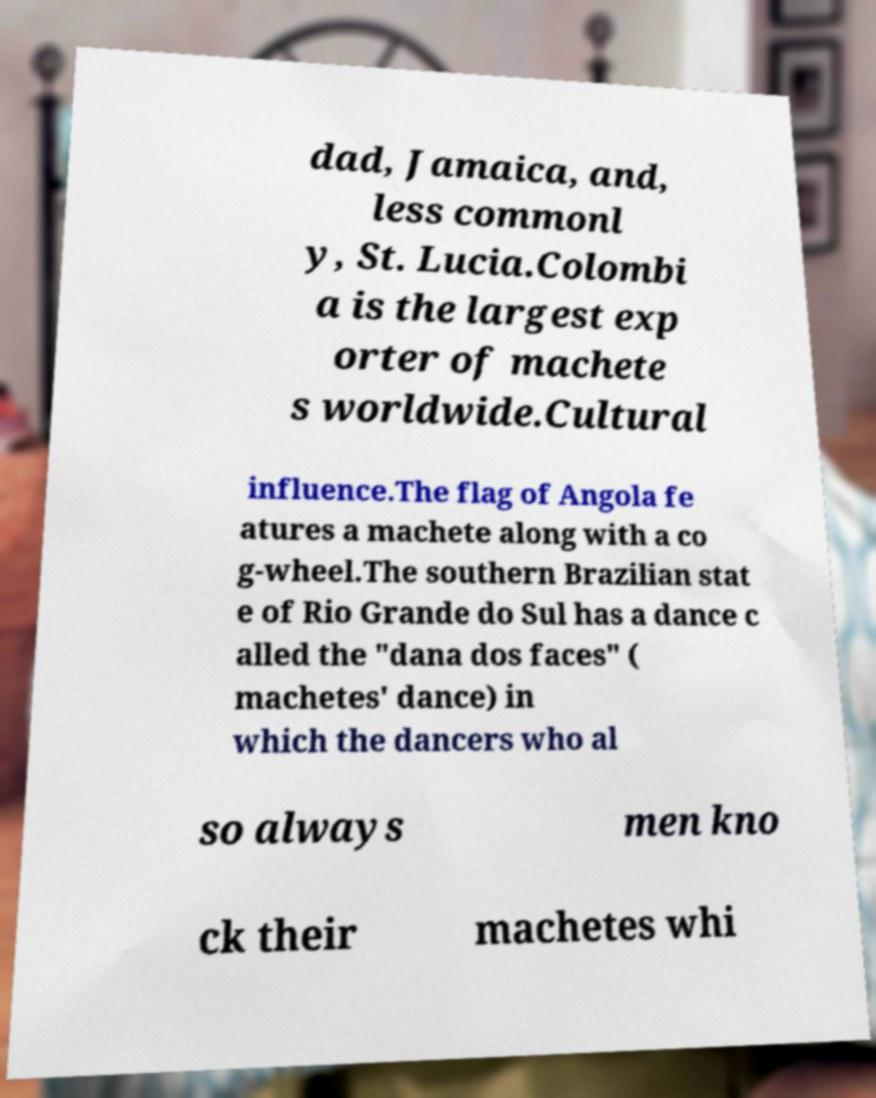I need the written content from this picture converted into text. Can you do that? dad, Jamaica, and, less commonl y, St. Lucia.Colombi a is the largest exp orter of machete s worldwide.Cultural influence.The flag of Angola fe atures a machete along with a co g-wheel.The southern Brazilian stat e of Rio Grande do Sul has a dance c alled the "dana dos faces" ( machetes' dance) in which the dancers who al so always men kno ck their machetes whi 